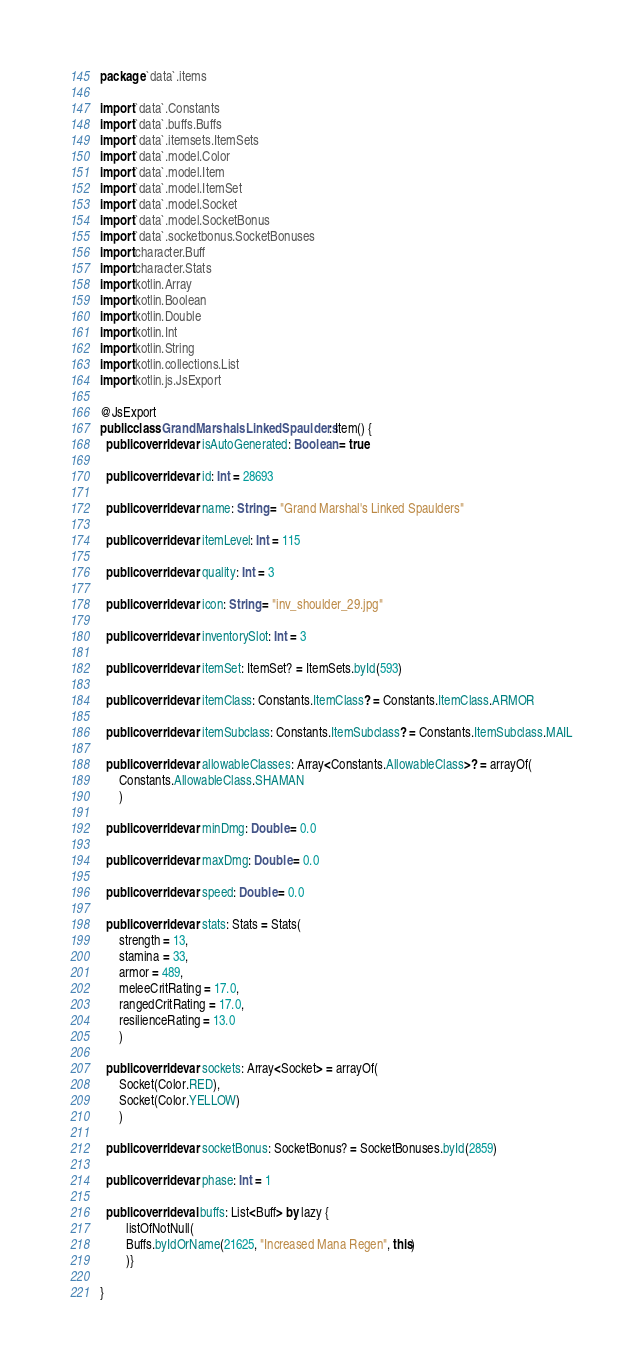Convert code to text. <code><loc_0><loc_0><loc_500><loc_500><_Kotlin_>package `data`.items

import `data`.Constants
import `data`.buffs.Buffs
import `data`.itemsets.ItemSets
import `data`.model.Color
import `data`.model.Item
import `data`.model.ItemSet
import `data`.model.Socket
import `data`.model.SocketBonus
import `data`.socketbonus.SocketBonuses
import character.Buff
import character.Stats
import kotlin.Array
import kotlin.Boolean
import kotlin.Double
import kotlin.Int
import kotlin.String
import kotlin.collections.List
import kotlin.js.JsExport

@JsExport
public class GrandMarshalsLinkedSpaulders : Item() {
  public override var isAutoGenerated: Boolean = true

  public override var id: Int = 28693

  public override var name: String = "Grand Marshal's Linked Spaulders"

  public override var itemLevel: Int = 115

  public override var quality: Int = 3

  public override var icon: String = "inv_shoulder_29.jpg"

  public override var inventorySlot: Int = 3

  public override var itemSet: ItemSet? = ItemSets.byId(593)

  public override var itemClass: Constants.ItemClass? = Constants.ItemClass.ARMOR

  public override var itemSubclass: Constants.ItemSubclass? = Constants.ItemSubclass.MAIL

  public override var allowableClasses: Array<Constants.AllowableClass>? = arrayOf(
      Constants.AllowableClass.SHAMAN
      )

  public override var minDmg: Double = 0.0

  public override var maxDmg: Double = 0.0

  public override var speed: Double = 0.0

  public override var stats: Stats = Stats(
      strength = 13,
      stamina = 33,
      armor = 489,
      meleeCritRating = 17.0,
      rangedCritRating = 17.0,
      resilienceRating = 13.0
      )

  public override var sockets: Array<Socket> = arrayOf(
      Socket(Color.RED),
      Socket(Color.YELLOW)
      )

  public override var socketBonus: SocketBonus? = SocketBonuses.byId(2859)

  public override var phase: Int = 1

  public override val buffs: List<Buff> by lazy {
        listOfNotNull(
        Buffs.byIdOrName(21625, "Increased Mana Regen", this)
        )}

}
</code> 